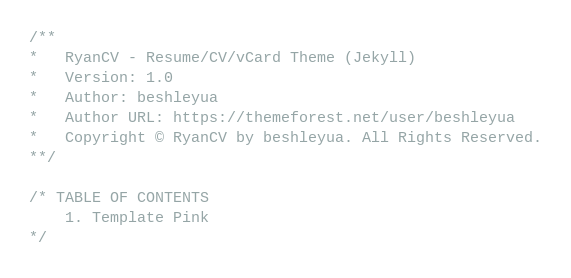Convert code to text. <code><loc_0><loc_0><loc_500><loc_500><_CSS_>/**
*   RyanCV - Resume/CV/vCard Theme (Jekyll)
*   Version: 1.0
*   Author: beshleyua
*   Author URL: https://themeforest.net/user/beshleyua
*   Copyright © RyanCV by beshleyua. All Rights Reserved.
**/

/* TABLE OF CONTENTS
	1. Template Pink
*/
</code> 